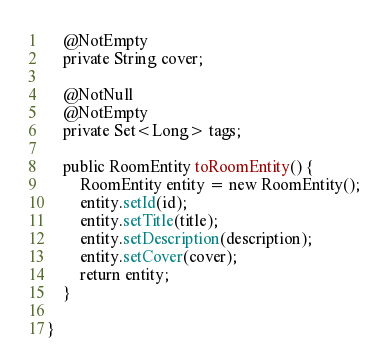Convert code to text. <code><loc_0><loc_0><loc_500><loc_500><_Java_>
    @NotEmpty
    private String cover;

    @NotNull
    @NotEmpty
    private Set<Long> tags;

    public RoomEntity toRoomEntity() {
        RoomEntity entity = new RoomEntity();
        entity.setId(id);
        entity.setTitle(title);
        entity.setDescription(description);
        entity.setCover(cover);
        return entity;
    }

}
</code> 